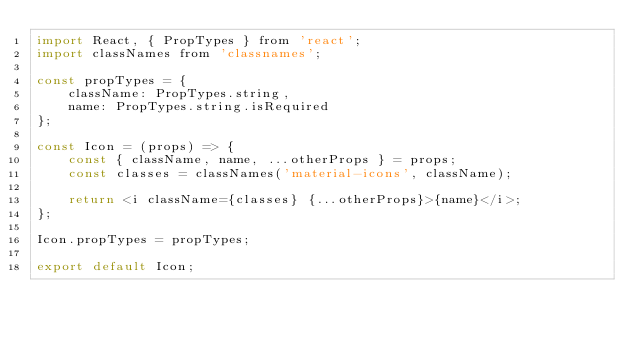Convert code to text. <code><loc_0><loc_0><loc_500><loc_500><_JavaScript_>import React, { PropTypes } from 'react';
import classNames from 'classnames';

const propTypes = {
    className: PropTypes.string,
    name: PropTypes.string.isRequired
};

const Icon = (props) => {
    const { className, name, ...otherProps } = props;
    const classes = classNames('material-icons', className);

    return <i className={classes} {...otherProps}>{name}</i>;
};

Icon.propTypes = propTypes;

export default Icon;
</code> 